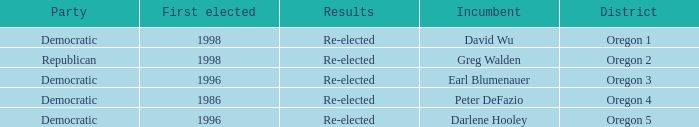What was the result of the Oregon 5 District incumbent who was first elected in 1996? Re-elected. 